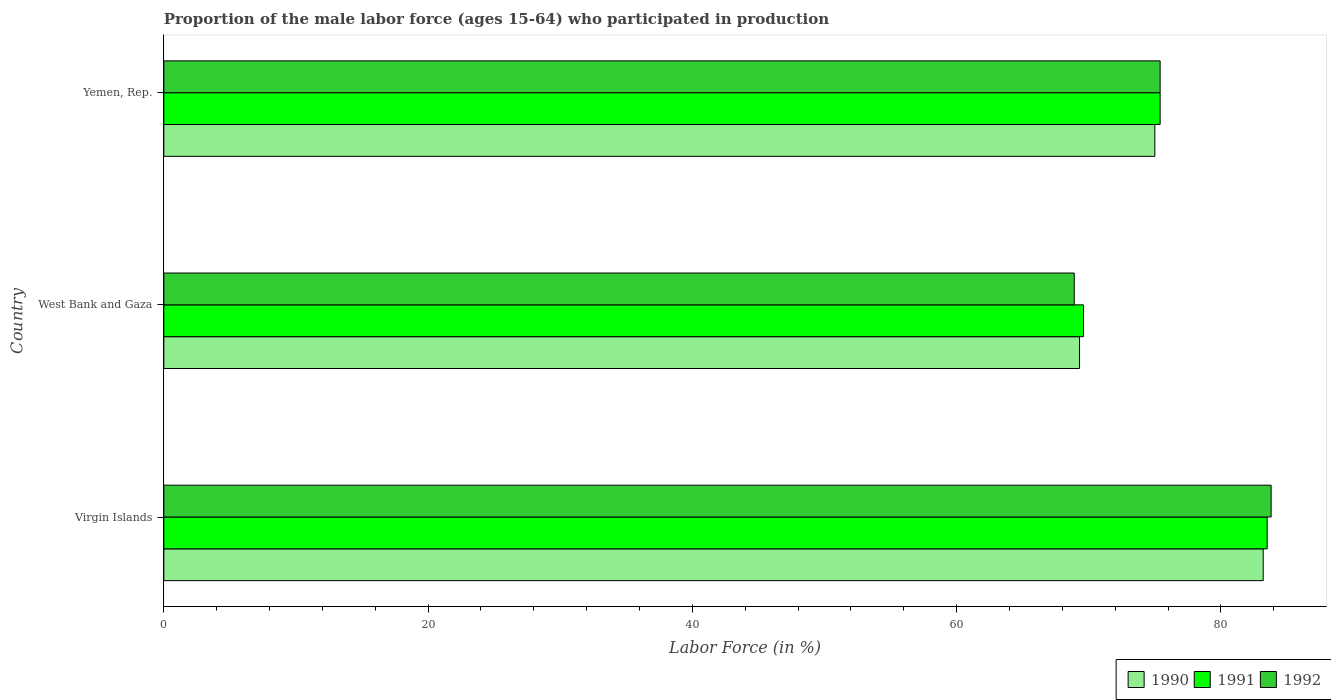How many groups of bars are there?
Give a very brief answer. 3. Are the number of bars per tick equal to the number of legend labels?
Provide a short and direct response. Yes. How many bars are there on the 1st tick from the top?
Provide a succinct answer. 3. What is the label of the 3rd group of bars from the top?
Provide a succinct answer. Virgin Islands. What is the proportion of the male labor force who participated in production in 1990 in Yemen, Rep.?
Your answer should be very brief. 75. Across all countries, what is the maximum proportion of the male labor force who participated in production in 1990?
Make the answer very short. 83.2. Across all countries, what is the minimum proportion of the male labor force who participated in production in 1991?
Provide a succinct answer. 69.6. In which country was the proportion of the male labor force who participated in production in 1992 maximum?
Your answer should be very brief. Virgin Islands. In which country was the proportion of the male labor force who participated in production in 1992 minimum?
Offer a very short reply. West Bank and Gaza. What is the total proportion of the male labor force who participated in production in 1992 in the graph?
Keep it short and to the point. 228.1. What is the difference between the proportion of the male labor force who participated in production in 1992 in West Bank and Gaza and that in Yemen, Rep.?
Make the answer very short. -6.5. What is the difference between the proportion of the male labor force who participated in production in 1990 in Virgin Islands and the proportion of the male labor force who participated in production in 1992 in Yemen, Rep.?
Provide a succinct answer. 7.8. What is the average proportion of the male labor force who participated in production in 1991 per country?
Provide a short and direct response. 76.17. What is the ratio of the proportion of the male labor force who participated in production in 1992 in Virgin Islands to that in Yemen, Rep.?
Keep it short and to the point. 1.11. Is the proportion of the male labor force who participated in production in 1991 in Virgin Islands less than that in West Bank and Gaza?
Give a very brief answer. No. Is the difference between the proportion of the male labor force who participated in production in 1992 in West Bank and Gaza and Yemen, Rep. greater than the difference between the proportion of the male labor force who participated in production in 1991 in West Bank and Gaza and Yemen, Rep.?
Make the answer very short. No. What is the difference between the highest and the second highest proportion of the male labor force who participated in production in 1992?
Your answer should be very brief. 8.4. What is the difference between the highest and the lowest proportion of the male labor force who participated in production in 1991?
Offer a very short reply. 13.9. In how many countries, is the proportion of the male labor force who participated in production in 1990 greater than the average proportion of the male labor force who participated in production in 1990 taken over all countries?
Your response must be concise. 1. Is the sum of the proportion of the male labor force who participated in production in 1990 in West Bank and Gaza and Yemen, Rep. greater than the maximum proportion of the male labor force who participated in production in 1992 across all countries?
Your response must be concise. Yes. What does the 3rd bar from the top in Yemen, Rep. represents?
Offer a very short reply. 1990. Are all the bars in the graph horizontal?
Offer a very short reply. Yes. Are the values on the major ticks of X-axis written in scientific E-notation?
Provide a short and direct response. No. Does the graph contain any zero values?
Your answer should be very brief. No. Does the graph contain grids?
Ensure brevity in your answer.  No. Where does the legend appear in the graph?
Make the answer very short. Bottom right. How many legend labels are there?
Give a very brief answer. 3. How are the legend labels stacked?
Give a very brief answer. Horizontal. What is the title of the graph?
Give a very brief answer. Proportion of the male labor force (ages 15-64) who participated in production. Does "2009" appear as one of the legend labels in the graph?
Offer a terse response. No. What is the label or title of the X-axis?
Your response must be concise. Labor Force (in %). What is the label or title of the Y-axis?
Keep it short and to the point. Country. What is the Labor Force (in %) in 1990 in Virgin Islands?
Your response must be concise. 83.2. What is the Labor Force (in %) in 1991 in Virgin Islands?
Provide a short and direct response. 83.5. What is the Labor Force (in %) in 1992 in Virgin Islands?
Make the answer very short. 83.8. What is the Labor Force (in %) in 1990 in West Bank and Gaza?
Your answer should be very brief. 69.3. What is the Labor Force (in %) of 1991 in West Bank and Gaza?
Your answer should be very brief. 69.6. What is the Labor Force (in %) in 1992 in West Bank and Gaza?
Provide a succinct answer. 68.9. What is the Labor Force (in %) in 1990 in Yemen, Rep.?
Provide a short and direct response. 75. What is the Labor Force (in %) of 1991 in Yemen, Rep.?
Give a very brief answer. 75.4. What is the Labor Force (in %) of 1992 in Yemen, Rep.?
Provide a short and direct response. 75.4. Across all countries, what is the maximum Labor Force (in %) in 1990?
Give a very brief answer. 83.2. Across all countries, what is the maximum Labor Force (in %) in 1991?
Your response must be concise. 83.5. Across all countries, what is the maximum Labor Force (in %) of 1992?
Keep it short and to the point. 83.8. Across all countries, what is the minimum Labor Force (in %) in 1990?
Your answer should be compact. 69.3. Across all countries, what is the minimum Labor Force (in %) of 1991?
Your answer should be very brief. 69.6. Across all countries, what is the minimum Labor Force (in %) in 1992?
Give a very brief answer. 68.9. What is the total Labor Force (in %) of 1990 in the graph?
Give a very brief answer. 227.5. What is the total Labor Force (in %) of 1991 in the graph?
Ensure brevity in your answer.  228.5. What is the total Labor Force (in %) of 1992 in the graph?
Keep it short and to the point. 228.1. What is the difference between the Labor Force (in %) in 1990 in Virgin Islands and that in West Bank and Gaza?
Your answer should be very brief. 13.9. What is the difference between the Labor Force (in %) of 1991 in Virgin Islands and that in West Bank and Gaza?
Ensure brevity in your answer.  13.9. What is the difference between the Labor Force (in %) of 1990 in Virgin Islands and that in Yemen, Rep.?
Ensure brevity in your answer.  8.2. What is the difference between the Labor Force (in %) of 1991 in Virgin Islands and that in Yemen, Rep.?
Ensure brevity in your answer.  8.1. What is the difference between the Labor Force (in %) of 1992 in Virgin Islands and that in Yemen, Rep.?
Keep it short and to the point. 8.4. What is the difference between the Labor Force (in %) of 1990 in Virgin Islands and the Labor Force (in %) of 1991 in West Bank and Gaza?
Offer a very short reply. 13.6. What is the difference between the Labor Force (in %) in 1990 in Virgin Islands and the Labor Force (in %) in 1992 in West Bank and Gaza?
Give a very brief answer. 14.3. What is the difference between the Labor Force (in %) of 1991 in Virgin Islands and the Labor Force (in %) of 1992 in West Bank and Gaza?
Offer a terse response. 14.6. What is the difference between the Labor Force (in %) in 1991 in Virgin Islands and the Labor Force (in %) in 1992 in Yemen, Rep.?
Your answer should be very brief. 8.1. What is the difference between the Labor Force (in %) of 1990 in West Bank and Gaza and the Labor Force (in %) of 1991 in Yemen, Rep.?
Your answer should be very brief. -6.1. What is the difference between the Labor Force (in %) of 1990 in West Bank and Gaza and the Labor Force (in %) of 1992 in Yemen, Rep.?
Your answer should be very brief. -6.1. What is the average Labor Force (in %) in 1990 per country?
Make the answer very short. 75.83. What is the average Labor Force (in %) in 1991 per country?
Offer a very short reply. 76.17. What is the average Labor Force (in %) in 1992 per country?
Your response must be concise. 76.03. What is the difference between the Labor Force (in %) in 1990 and Labor Force (in %) in 1991 in West Bank and Gaza?
Your answer should be compact. -0.3. What is the difference between the Labor Force (in %) in 1990 and Labor Force (in %) in 1992 in West Bank and Gaza?
Your answer should be very brief. 0.4. What is the difference between the Labor Force (in %) in 1991 and Labor Force (in %) in 1992 in West Bank and Gaza?
Offer a very short reply. 0.7. What is the difference between the Labor Force (in %) in 1990 and Labor Force (in %) in 1992 in Yemen, Rep.?
Give a very brief answer. -0.4. What is the difference between the Labor Force (in %) of 1991 and Labor Force (in %) of 1992 in Yemen, Rep.?
Offer a very short reply. 0. What is the ratio of the Labor Force (in %) in 1990 in Virgin Islands to that in West Bank and Gaza?
Ensure brevity in your answer.  1.2. What is the ratio of the Labor Force (in %) in 1991 in Virgin Islands to that in West Bank and Gaza?
Your answer should be compact. 1.2. What is the ratio of the Labor Force (in %) in 1992 in Virgin Islands to that in West Bank and Gaza?
Offer a very short reply. 1.22. What is the ratio of the Labor Force (in %) of 1990 in Virgin Islands to that in Yemen, Rep.?
Keep it short and to the point. 1.11. What is the ratio of the Labor Force (in %) in 1991 in Virgin Islands to that in Yemen, Rep.?
Ensure brevity in your answer.  1.11. What is the ratio of the Labor Force (in %) of 1992 in Virgin Islands to that in Yemen, Rep.?
Your answer should be compact. 1.11. What is the ratio of the Labor Force (in %) in 1990 in West Bank and Gaza to that in Yemen, Rep.?
Ensure brevity in your answer.  0.92. What is the ratio of the Labor Force (in %) of 1991 in West Bank and Gaza to that in Yemen, Rep.?
Provide a succinct answer. 0.92. What is the ratio of the Labor Force (in %) of 1992 in West Bank and Gaza to that in Yemen, Rep.?
Provide a succinct answer. 0.91. What is the difference between the highest and the second highest Labor Force (in %) of 1991?
Provide a succinct answer. 8.1. What is the difference between the highest and the second highest Labor Force (in %) in 1992?
Offer a terse response. 8.4. What is the difference between the highest and the lowest Labor Force (in %) of 1990?
Offer a very short reply. 13.9. 